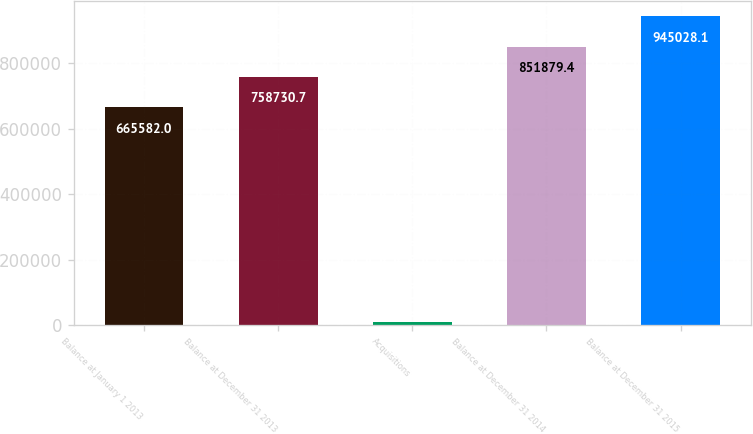Convert chart. <chart><loc_0><loc_0><loc_500><loc_500><bar_chart><fcel>Balance at January 1 2013<fcel>Balance at December 31 2013<fcel>Acquisitions<fcel>Balance at December 31 2014<fcel>Balance at December 31 2015<nl><fcel>665582<fcel>758731<fcel>9902<fcel>851879<fcel>945028<nl></chart> 